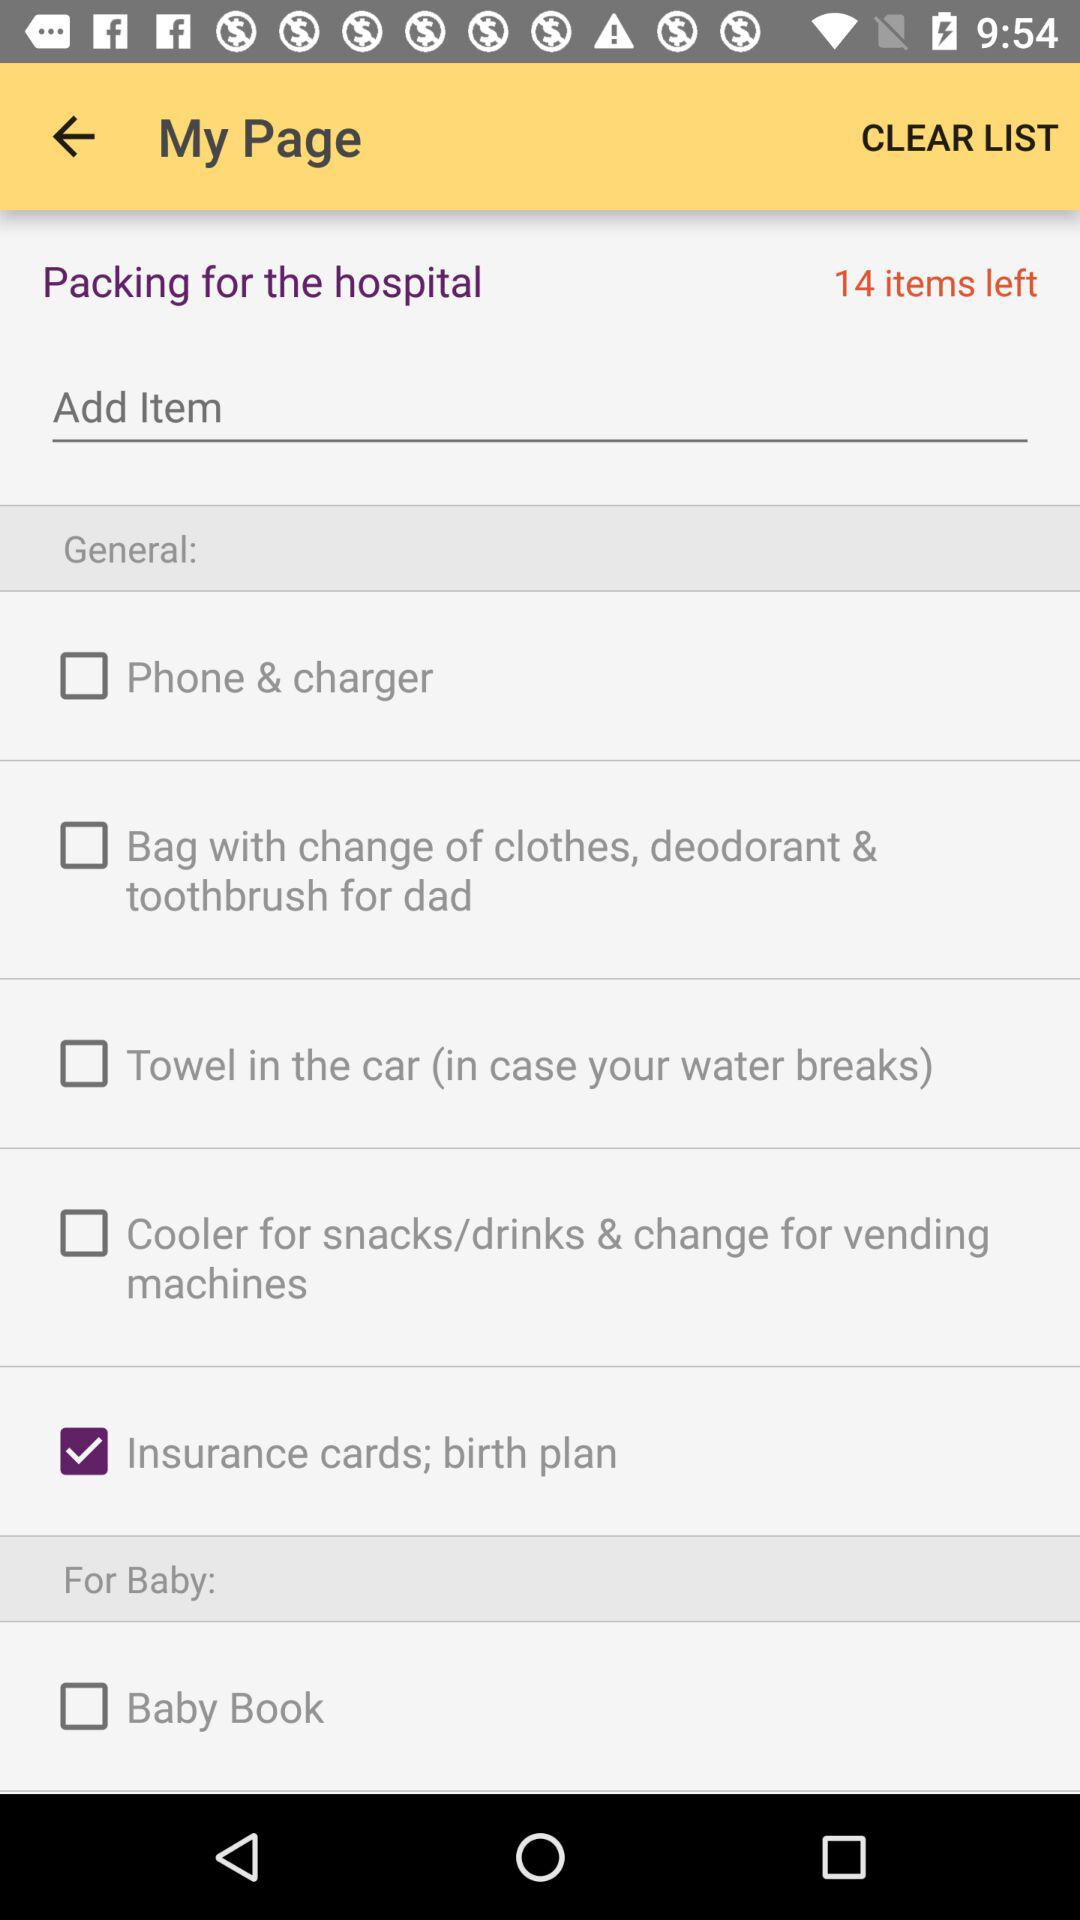How many more items are there in the General section than the For Baby section?
Answer the question using a single word or phrase. 4 